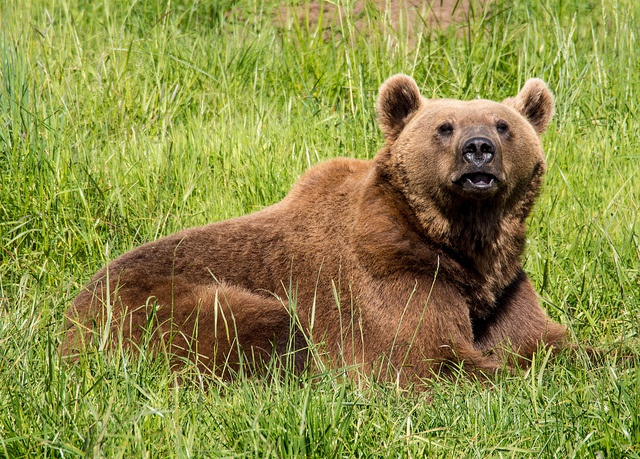Describe the objects in this image and their specific colors. I can see a bear in olive, gray, maroon, and black tones in this image. 